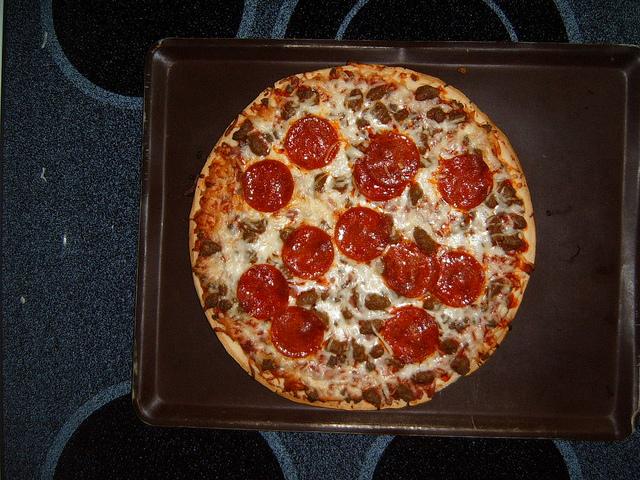What is this pizza on top of?
Be succinct. Tray. How many pieces of sausage are on the pizza?
Give a very brief answer. 30. Is this a store bought pizza?
Quick response, please. Yes. 